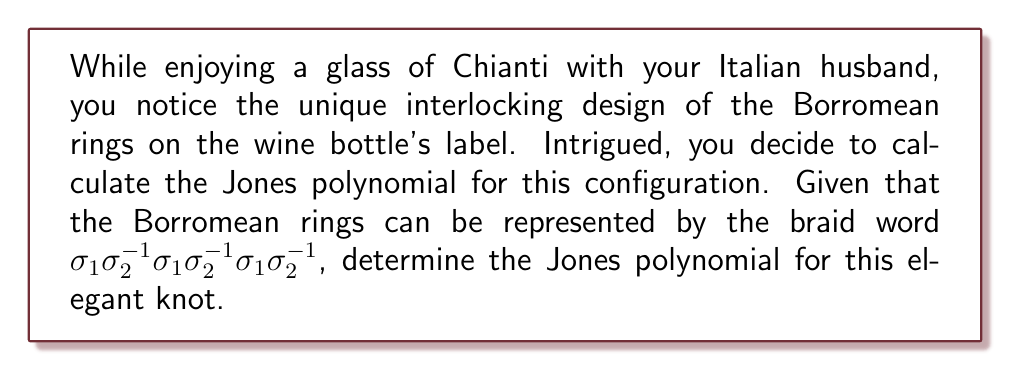What is the answer to this math problem? Let's calculate the Jones polynomial step-by-step:

1) First, we need to convert the braid word to a Kauffman bracket polynomial. The Kauffman bracket is defined as:
   $$\langle L \rangle = A\langle L_0 \rangle + A^{-1}\langle L_\infty \rangle$$
   where $L_0$ is the smoothing that separates the strands and $L_\infty$ is the smoothing that connects the strands.

2) For our braid word $\sigma_1\sigma_2^{-1}\sigma_1\sigma_2^{-1}\sigma_1\sigma_2^{-1}$, we have:
   $$\langle \sigma_1 \rangle = A\langle I \rangle + A^{-1}\langle H \rangle$$
   $$\langle \sigma_2^{-1} \rangle = A^{-1}\langle I \rangle + A\langle H \rangle$$
   where $I$ is the identity (two parallel strands) and $H$ is the horizontal connection.

3) Applying these repeatedly and simplifying, we get:
   $$\langle L \rangle = A^3\langle I \rangle + A^{-3}\langle H \rangle + 3A\langle H \rangle + 3A^{-1}\langle H \rangle$$

4) The writhe of this braid is $w(L) = 1$, as there are three positive crossings and two negative crossings.

5) The Jones polynomial is related to the Kauffman bracket by:
   $$V_L(t) = (-A^3)^{-w(L)}\langle L \rangle|_{A=t^{-1/4}}$$

6) Substituting and simplifying:
   $$V_L(t) = -t^{-3/4} - t^{-5/4} - t^{-7/4} + t^{1/4} + t^{3/4} + t^{5/4}$$

7) This can be further simplified to:
   $$V_L(t) = t^{-7/4}(-1 - t^{1/2} - t + t^2 + t^{5/2} + t^3)$$
Answer: $V_L(t) = t^{-7/4}(-1 - t^{1/2} - t + t^2 + t^{5/2} + t^3)$ 